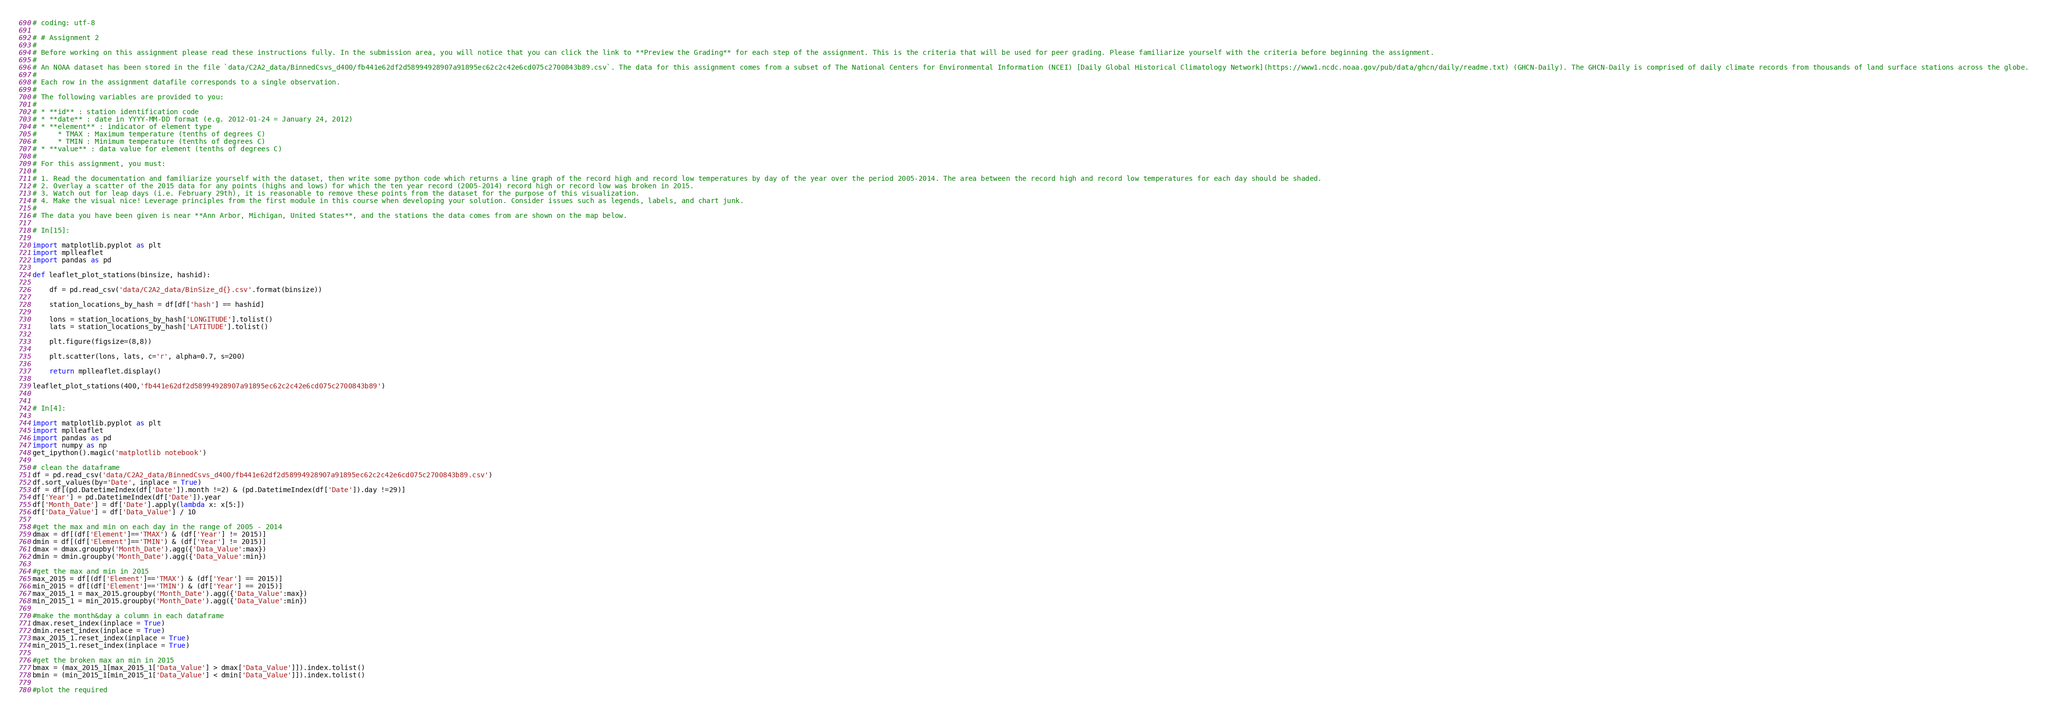Convert code to text. <code><loc_0><loc_0><loc_500><loc_500><_Python_>
# coding: utf-8

# # Assignment 2
# 
# Before working on this assignment please read these instructions fully. In the submission area, you will notice that you can click the link to **Preview the Grading** for each step of the assignment. This is the criteria that will be used for peer grading. Please familiarize yourself with the criteria before beginning the assignment.
# 
# An NOAA dataset has been stored in the file `data/C2A2_data/BinnedCsvs_d400/fb441e62df2d58994928907a91895ec62c2c42e6cd075c2700843b89.csv`. The data for this assignment comes from a subset of The National Centers for Environmental Information (NCEI) [Daily Global Historical Climatology Network](https://www1.ncdc.noaa.gov/pub/data/ghcn/daily/readme.txt) (GHCN-Daily). The GHCN-Daily is comprised of daily climate records from thousands of land surface stations across the globe.
# 
# Each row in the assignment datafile corresponds to a single observation.
# 
# The following variables are provided to you:
# 
# * **id** : station identification code
# * **date** : date in YYYY-MM-DD format (e.g. 2012-01-24 = January 24, 2012)
# * **element** : indicator of element type
#     * TMAX : Maximum temperature (tenths of degrees C)
#     * TMIN : Minimum temperature (tenths of degrees C)
# * **value** : data value for element (tenths of degrees C)
# 
# For this assignment, you must:
# 
# 1. Read the documentation and familiarize yourself with the dataset, then write some python code which returns a line graph of the record high and record low temperatures by day of the year over the period 2005-2014. The area between the record high and record low temperatures for each day should be shaded.
# 2. Overlay a scatter of the 2015 data for any points (highs and lows) for which the ten year record (2005-2014) record high or record low was broken in 2015.
# 3. Watch out for leap days (i.e. February 29th), it is reasonable to remove these points from the dataset for the purpose of this visualization.
# 4. Make the visual nice! Leverage principles from the first module in this course when developing your solution. Consider issues such as legends, labels, and chart junk.
# 
# The data you have been given is near **Ann Arbor, Michigan, United States**, and the stations the data comes from are shown on the map below.

# In[15]:

import matplotlib.pyplot as plt
import mplleaflet
import pandas as pd

def leaflet_plot_stations(binsize, hashid):

    df = pd.read_csv('data/C2A2_data/BinSize_d{}.csv'.format(binsize))
    
    station_locations_by_hash = df[df['hash'] == hashid]

    lons = station_locations_by_hash['LONGITUDE'].tolist()
    lats = station_locations_by_hash['LATITUDE'].tolist()

    plt.figure(figsize=(8,8))

    plt.scatter(lons, lats, c='r', alpha=0.7, s=200)

    return mplleaflet.display()

leaflet_plot_stations(400,'fb441e62df2d58994928907a91895ec62c2c42e6cd075c2700843b89')


# In[4]:

import matplotlib.pyplot as plt
import mplleaflet
import pandas as pd
import numpy as np
get_ipython().magic('matplotlib notebook')

# clean the dataframe
df = pd.read_csv('data/C2A2_data/BinnedCsvs_d400/fb441e62df2d58994928907a91895ec62c2c42e6cd075c2700843b89.csv')
df.sort_values(by='Date', inplace = True)
df = df[(pd.DatetimeIndex(df['Date']).month !=2) & (pd.DatetimeIndex(df['Date']).day !=29)]
df['Year'] = pd.DatetimeIndex(df['Date']).year
df['Month_Date'] = df['Date'].apply(lambda x: x[5:])
df['Data_Value'] = df['Data_Value'] / 10

#get the max and min on each day in the range of 2005 - 2014
dmax = df[(df['Element']=='TMAX') & (df['Year'] != 2015)]
dmin = df[(df['Element']=='TMIN') & (df['Year'] != 2015)]
dmax = dmax.groupby('Month_Date').agg({'Data_Value':max})
dmin = dmin.groupby('Month_Date').agg({'Data_Value':min})

#get the max and min in 2015
max_2015 = df[(df['Element']=='TMAX') & (df['Year'] == 2015)]
min_2015 = df[(df['Element']=='TMIN') & (df['Year'] == 2015)]
max_2015_1 = max_2015.groupby('Month_Date').agg({'Data_Value':max})
min_2015_1 = min_2015.groupby('Month_Date').agg({'Data_Value':min})

#make the month&day a column in each dataframe
dmax.reset_index(inplace = True)
dmin.reset_index(inplace = True)
max_2015_1.reset_index(inplace = True)
min_2015_1.reset_index(inplace = True)

#get the broken max an min in 2015
bmax = (max_2015_1[max_2015_1['Data_Value'] > dmax['Data_Value']]).index.tolist()
bmin = (min_2015_1[min_2015_1['Data_Value'] < dmin['Data_Value']]).index.tolist()

#plot the required </code> 